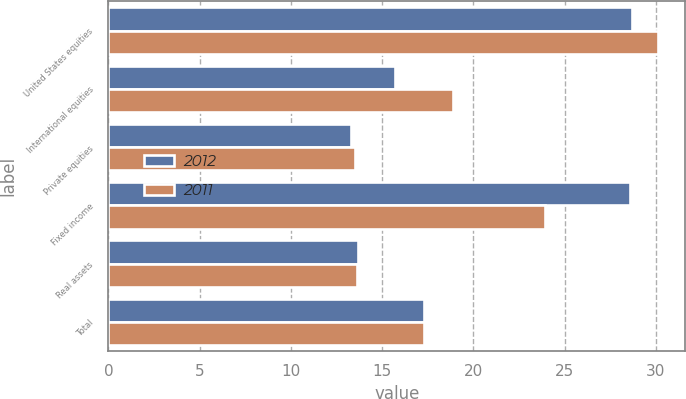<chart> <loc_0><loc_0><loc_500><loc_500><stacked_bar_chart><ecel><fcel>United States equities<fcel>International equities<fcel>Private equities<fcel>Fixed income<fcel>Real assets<fcel>Total<nl><fcel>2012<fcel>28.7<fcel>15.7<fcel>13.3<fcel>28.6<fcel>13.7<fcel>17.3<nl><fcel>2011<fcel>30.1<fcel>18.9<fcel>13.5<fcel>23.9<fcel>13.6<fcel>17.3<nl></chart> 